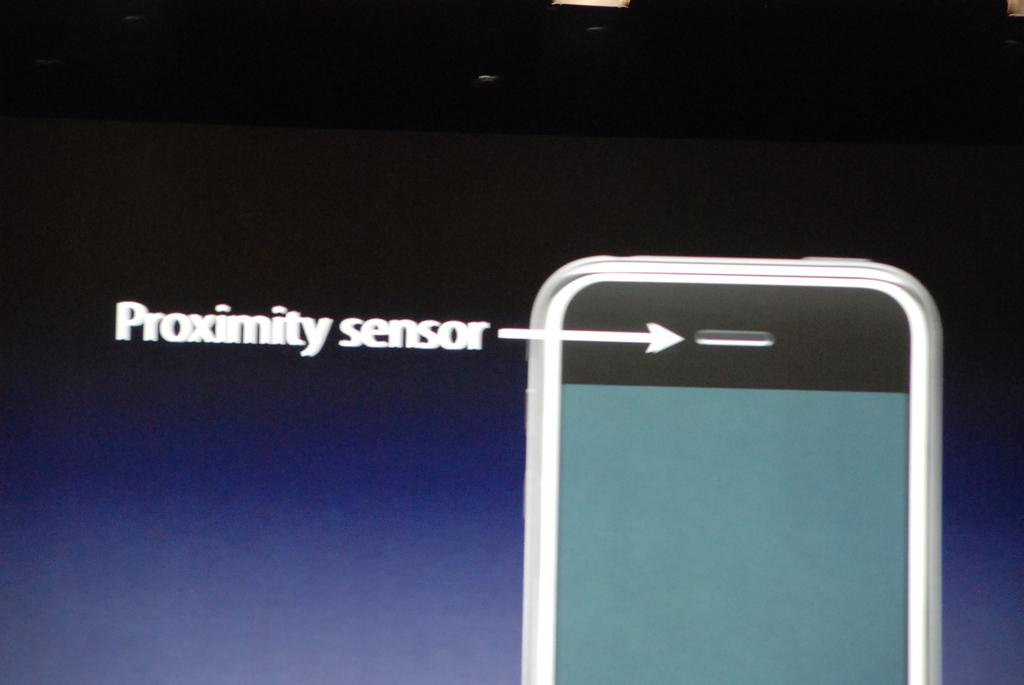Provide a one-sentence caption for the provided image. An image displaying the Proximity sensor on a cell phone. 